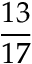Convert formula to latex. <formula><loc_0><loc_0><loc_500><loc_500>\frac { 1 3 } { 1 7 }</formula> 